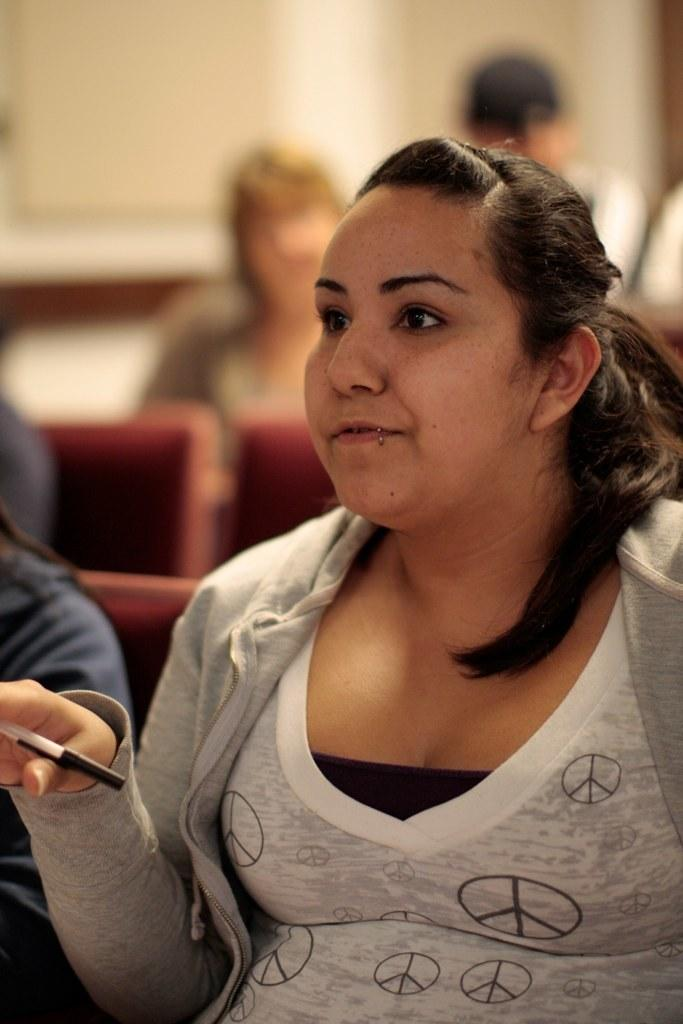How many people are in the image? There are people in the image, but the exact number cannot be determined from the provided facts. What is the lady holding in the image? The lady is holding an object in the image. Can you describe the lady's attire? The lady is wearing clothes in the image. What type of furniture is present in the image? There are chairs in the image. How would you describe the background of the image? The background of the image is blurred. What type of property does the lady own, as seen in the image? There is no information about property ownership in the image. How does the lady shake hands with the person next to her in the image? There is no person next to the lady in the image, and no handshaking is depicted. 